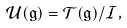Convert formula to latex. <formula><loc_0><loc_0><loc_500><loc_500>\mathcal { U } ( \mathfrak { g } ) = \mathcal { T } ( \mathfrak { g } ) / \mathcal { I } ,</formula> 